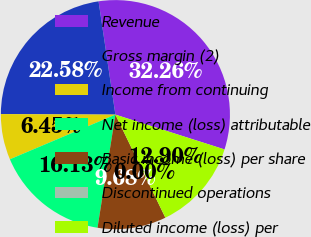Convert chart to OTSL. <chart><loc_0><loc_0><loc_500><loc_500><pie_chart><fcel>Revenue<fcel>Gross margin (2)<fcel>Income from continuing<fcel>Net income (loss) attributable<fcel>Basic income (loss) per share<fcel>Discontinued operations<fcel>Diluted income (loss) per<nl><fcel>32.26%<fcel>22.58%<fcel>6.45%<fcel>16.13%<fcel>9.68%<fcel>0.0%<fcel>12.9%<nl></chart> 